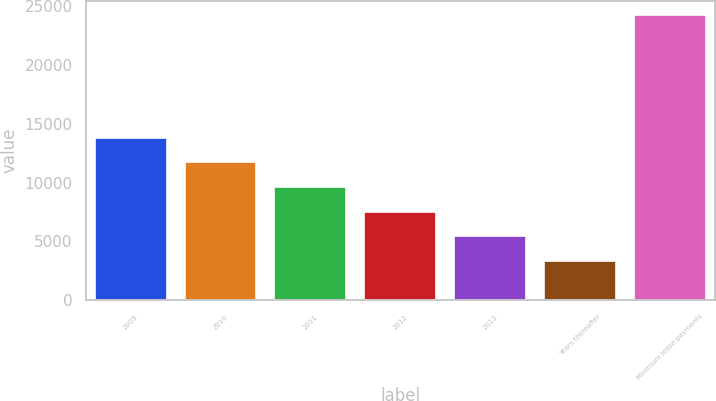Convert chart to OTSL. <chart><loc_0><loc_0><loc_500><loc_500><bar_chart><fcel>2009<fcel>2010<fcel>2011<fcel>2012<fcel>2013<fcel>Years thereafter<fcel>Minimum lease payments<nl><fcel>13801<fcel>11711<fcel>9621<fcel>7531<fcel>5441<fcel>3351<fcel>24251<nl></chart> 